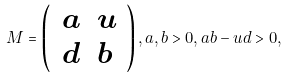Convert formula to latex. <formula><loc_0><loc_0><loc_500><loc_500>M = \left ( \, \begin{array} { c c } a & u \\ d & b \, \end{array} \right ) , a , b > 0 , a b - u d > 0 ,</formula> 